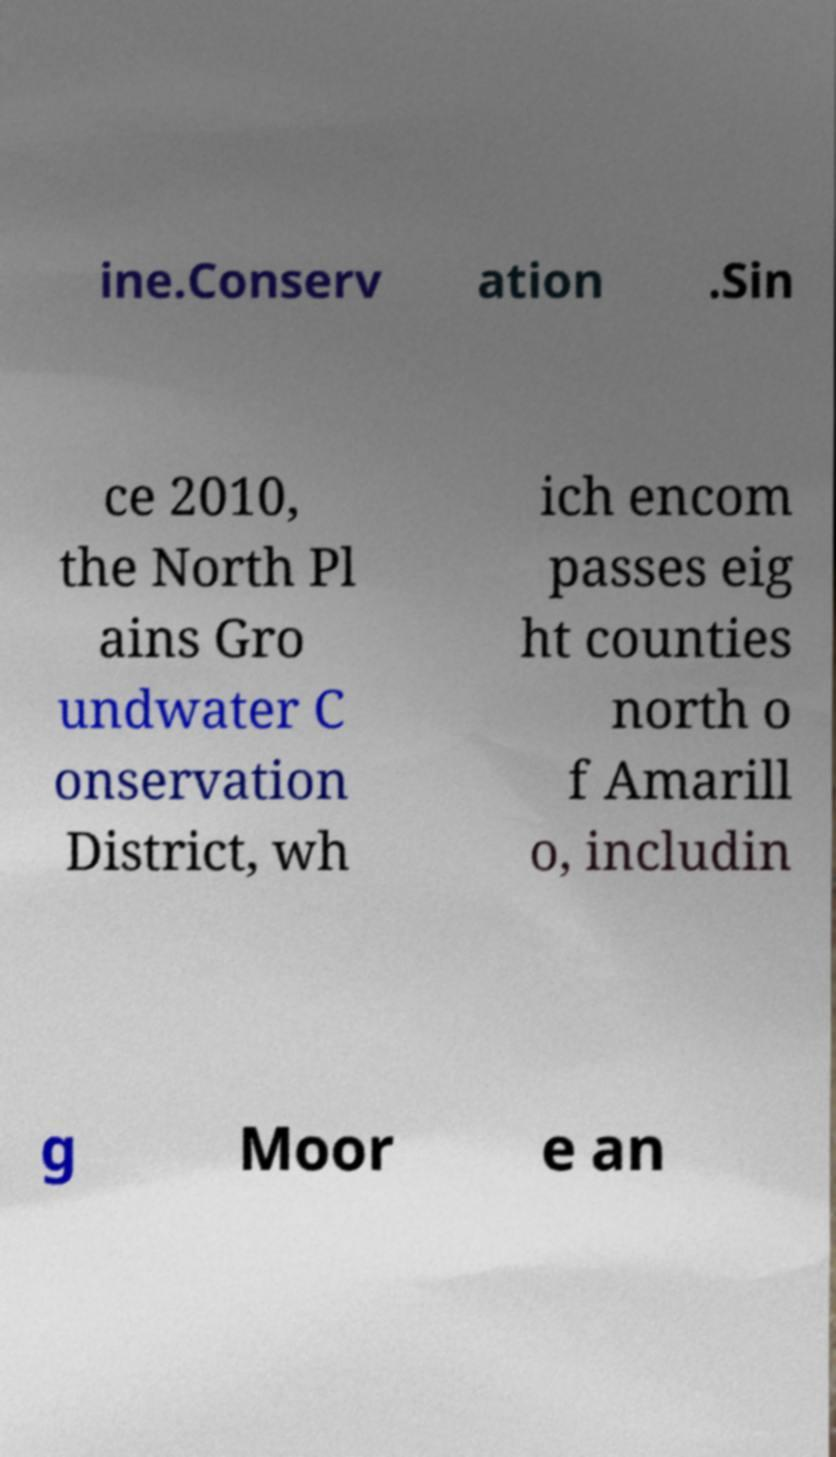Can you accurately transcribe the text from the provided image for me? ine.Conserv ation .Sin ce 2010, the North Pl ains Gro undwater C onservation District, wh ich encom passes eig ht counties north o f Amarill o, includin g Moor e an 